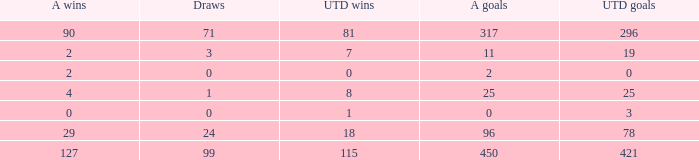What is the lowest Draws, when Alianza Goals is less than 317, when U Goals is less than 3, and when Alianza Wins is less than 2? None. 